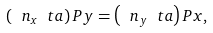<formula> <loc_0><loc_0><loc_500><loc_500>\left ( \ n _ { x } \ t a \right ) P y = \left ( \ n _ { y } \ t a \right ) P x ,</formula> 